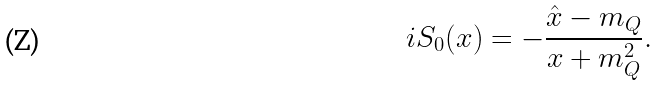<formula> <loc_0><loc_0><loc_500><loc_500>i S _ { 0 } ( x ) = - { \frac { \hat { x } - m _ { Q } } { x + m _ { Q } ^ { 2 } } } .</formula> 